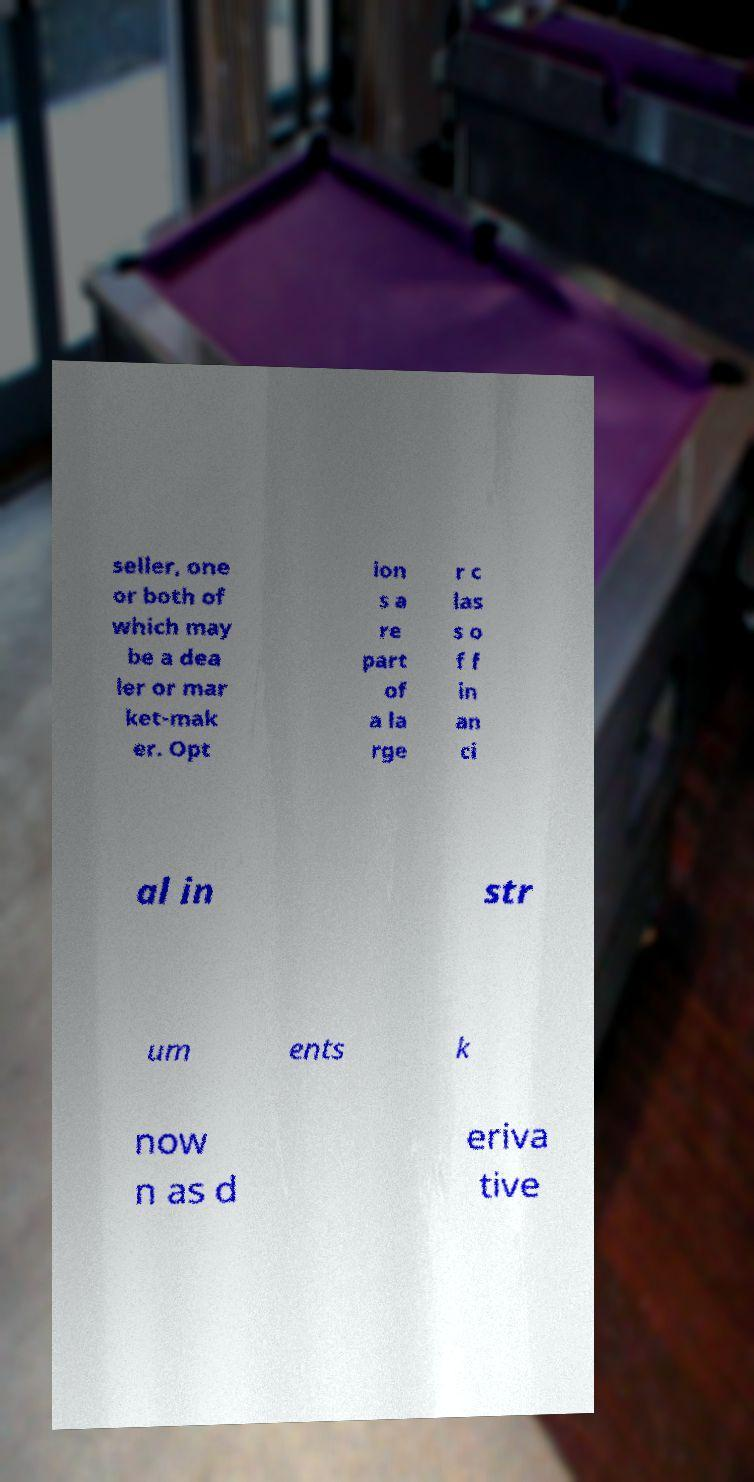Could you extract and type out the text from this image? seller, one or both of which may be a dea ler or mar ket-mak er. Opt ion s a re part of a la rge r c las s o f f in an ci al in str um ents k now n as d eriva tive 